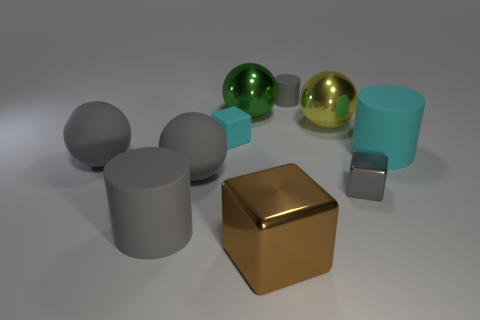Subtract all purple blocks. How many gray cylinders are left? 2 Subtract all tiny blocks. How many blocks are left? 1 Subtract all yellow balls. How many balls are left? 3 Subtract all cyan balls. Subtract all red cylinders. How many balls are left? 4 Subtract all balls. How many objects are left? 6 Add 3 green metallic balls. How many green metallic balls exist? 4 Subtract 0 cyan spheres. How many objects are left? 10 Subtract all large blue matte spheres. Subtract all cyan objects. How many objects are left? 8 Add 1 shiny blocks. How many shiny blocks are left? 3 